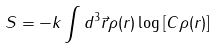<formula> <loc_0><loc_0><loc_500><loc_500>S = - k \int { d ^ { 3 } } \vec { r } \rho ( r ) \log \left [ { C \rho ( r ) } \right ]</formula> 